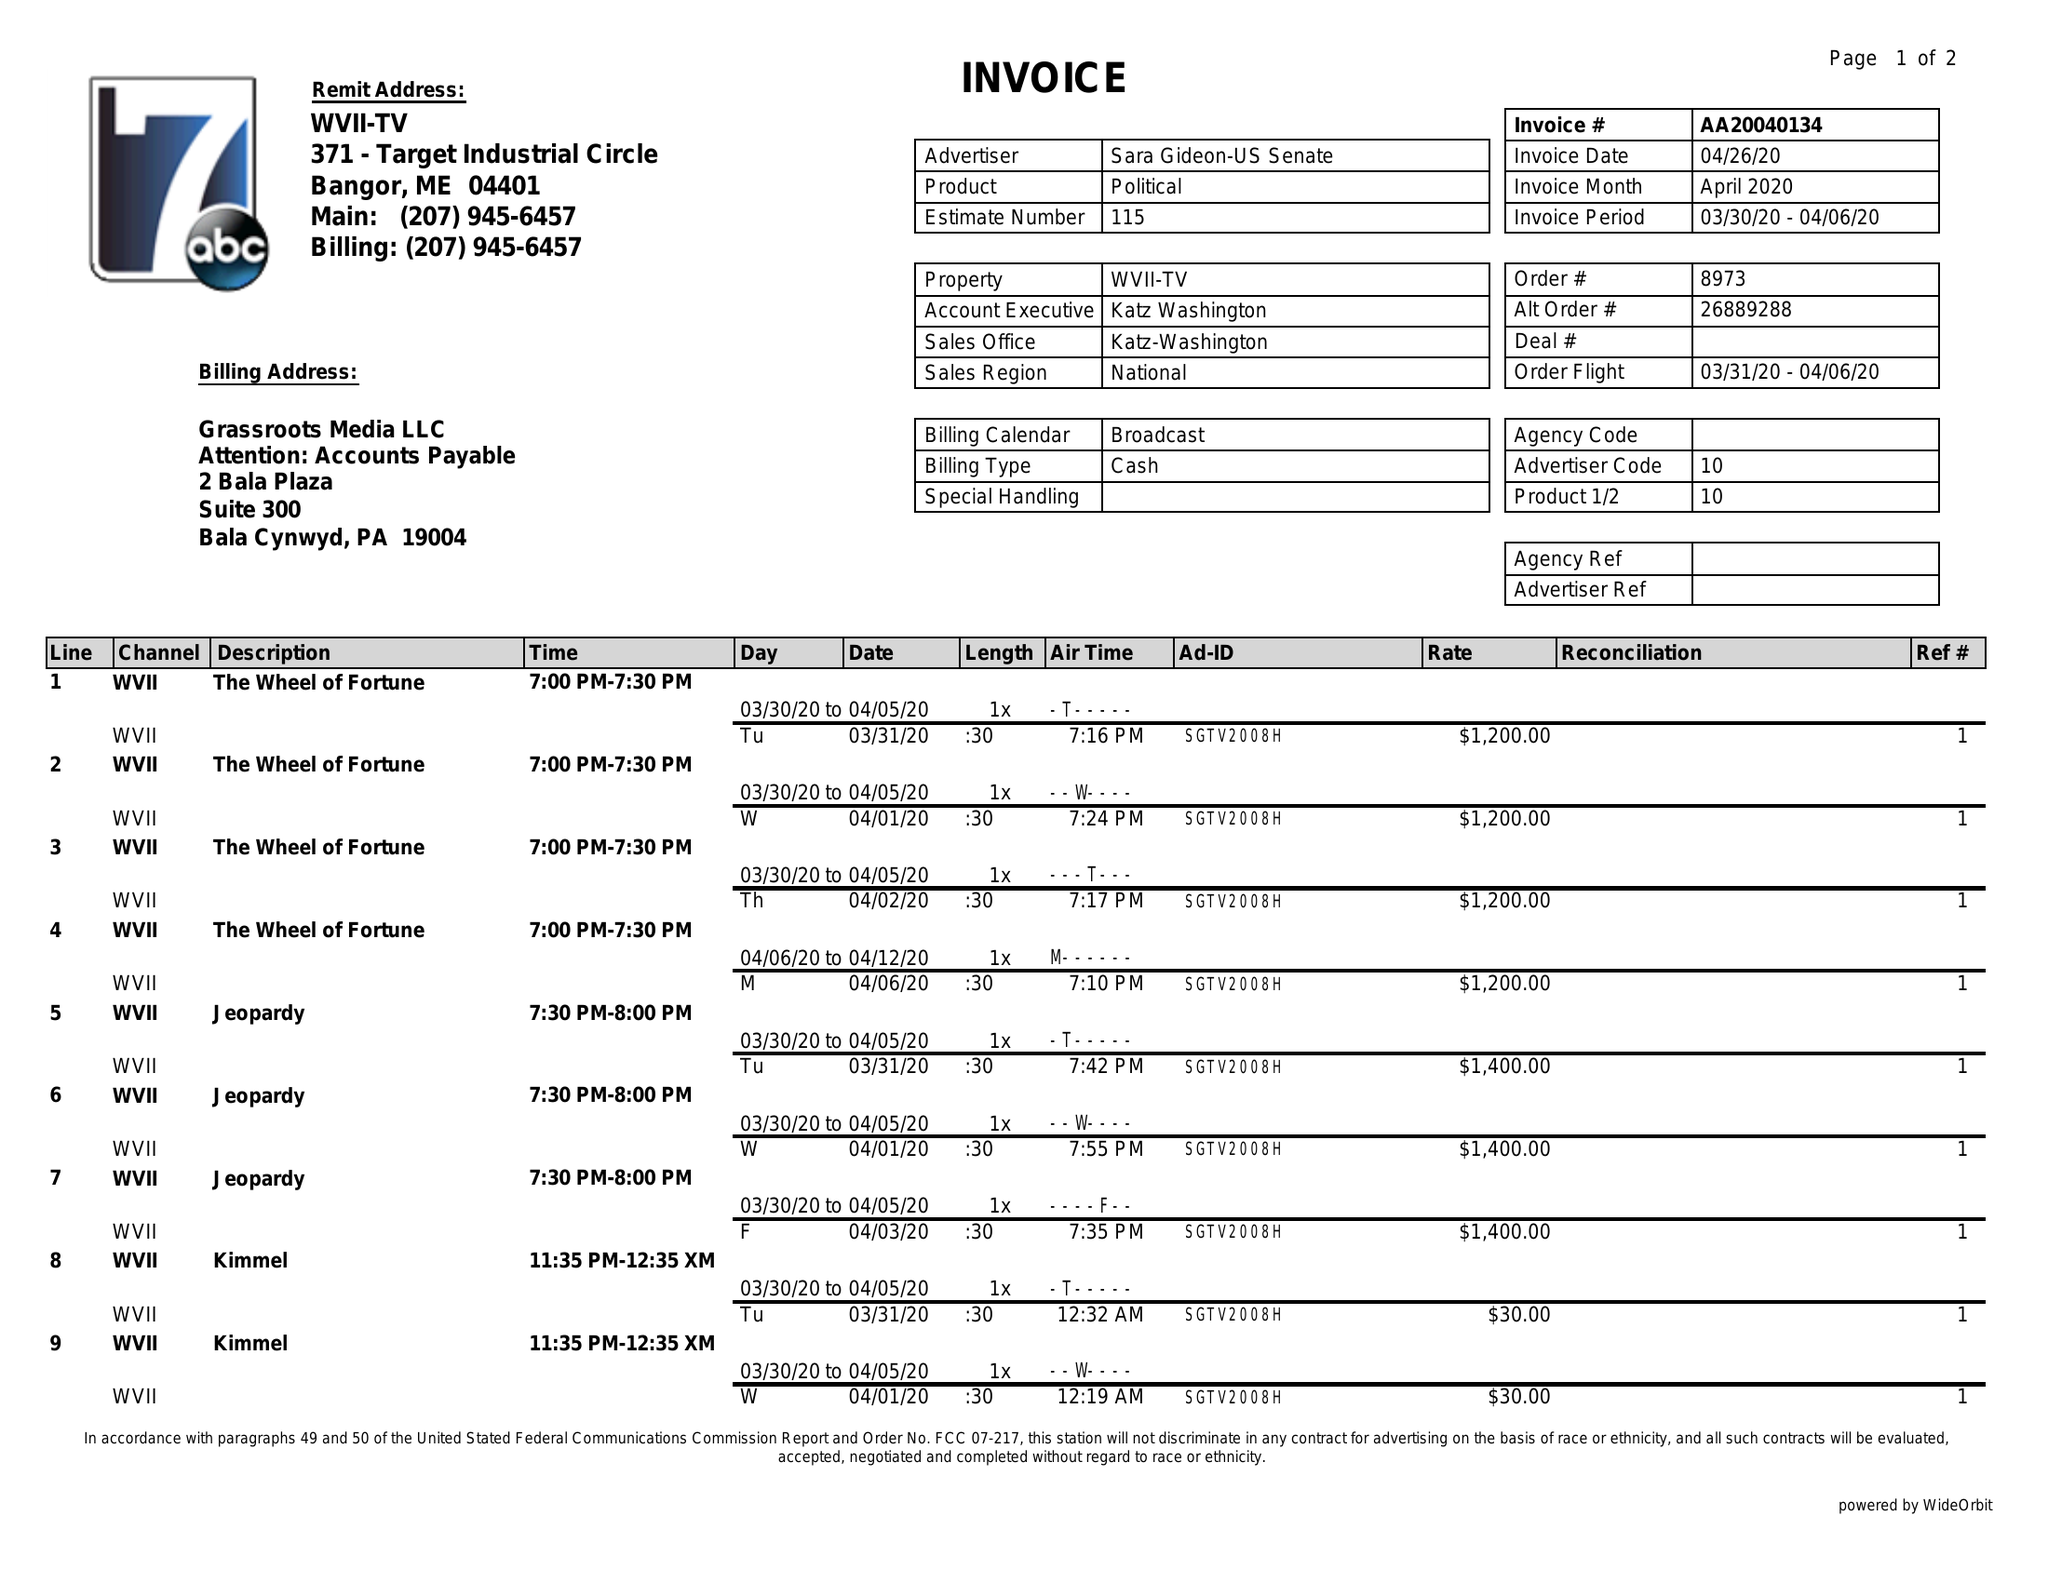What is the value for the advertiser?
Answer the question using a single word or phrase. SARA GIDEON-US SENATE 